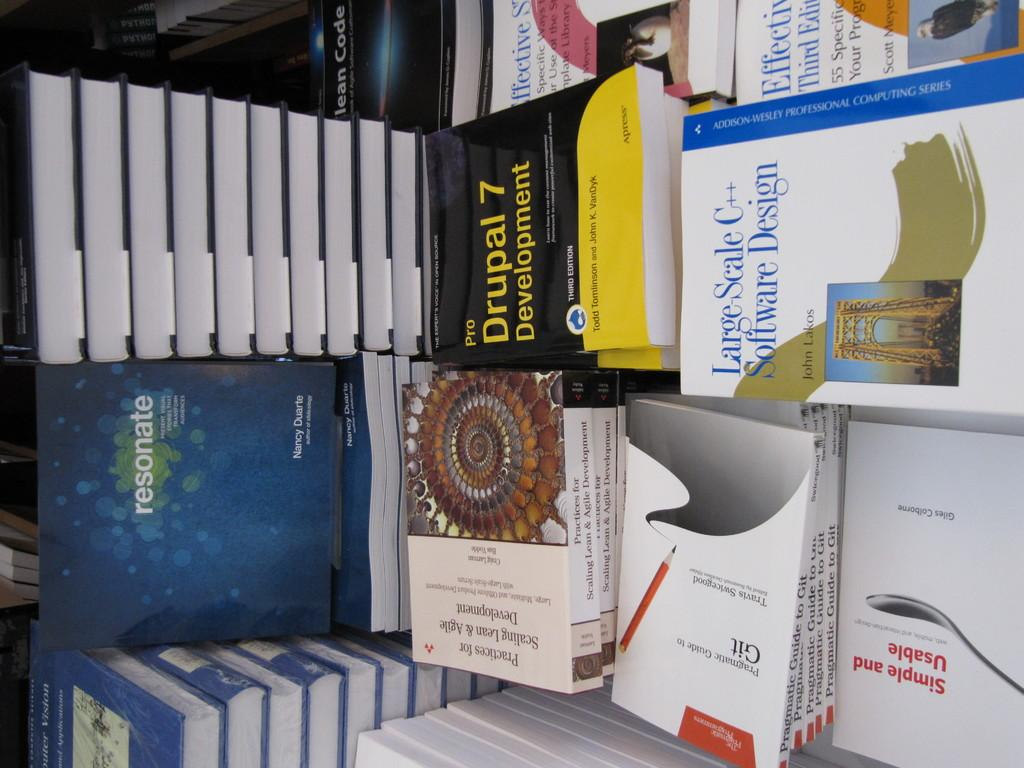<image>
Summarize the visual content of the image. Some books sit on a shelf including Pro Drupal 7 Development 